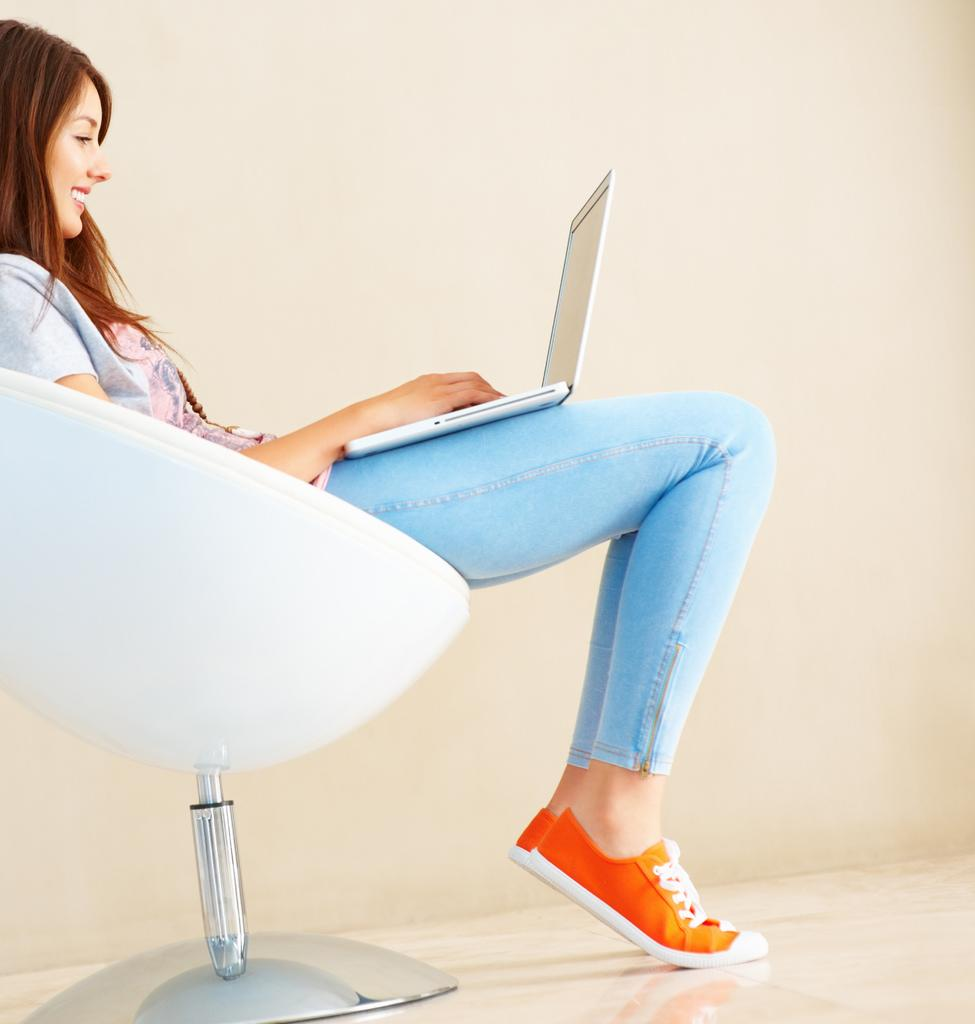What is the main subject of the image? The main subject of the image is a woman. What is the woman doing in the image? The woman is seated on a chair and using a laptop. What is the woman's facial expression in the image? The woman is smiling. What type of car can be seen in the image? There is no car present in the image. What is the air quality like in the image? The image does not provide any information about the air quality. 